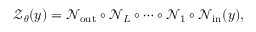<formula> <loc_0><loc_0><loc_500><loc_500>\mathcal { Z } _ { \theta } ( y ) = { \mathcal { N } } _ { o u t } \circ { \mathcal { N } } _ { L } \circ \cdots \circ { \mathcal { N } } _ { 1 } \circ { \mathcal { N } } _ { i n } ( y ) ,</formula> 